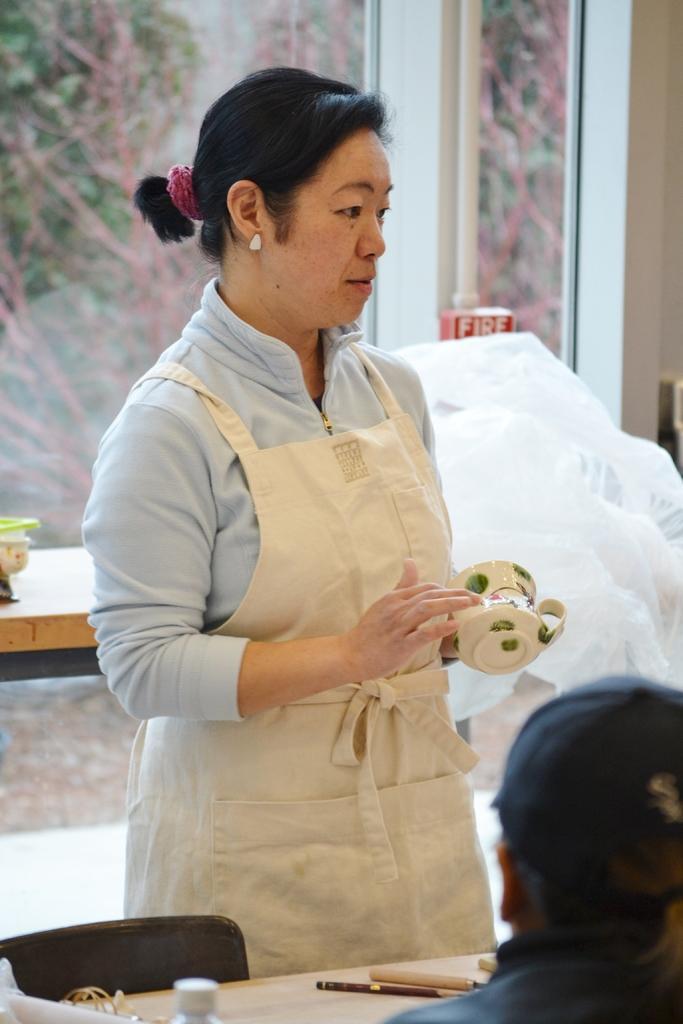In one or two sentences, can you explain what this image depicts? This is the picture of a lady who wore an apron and holding a cup in her hand and standing in front of the table on which there are some pens and a bottle and a person in front of the table and behind her there is a glass door. 